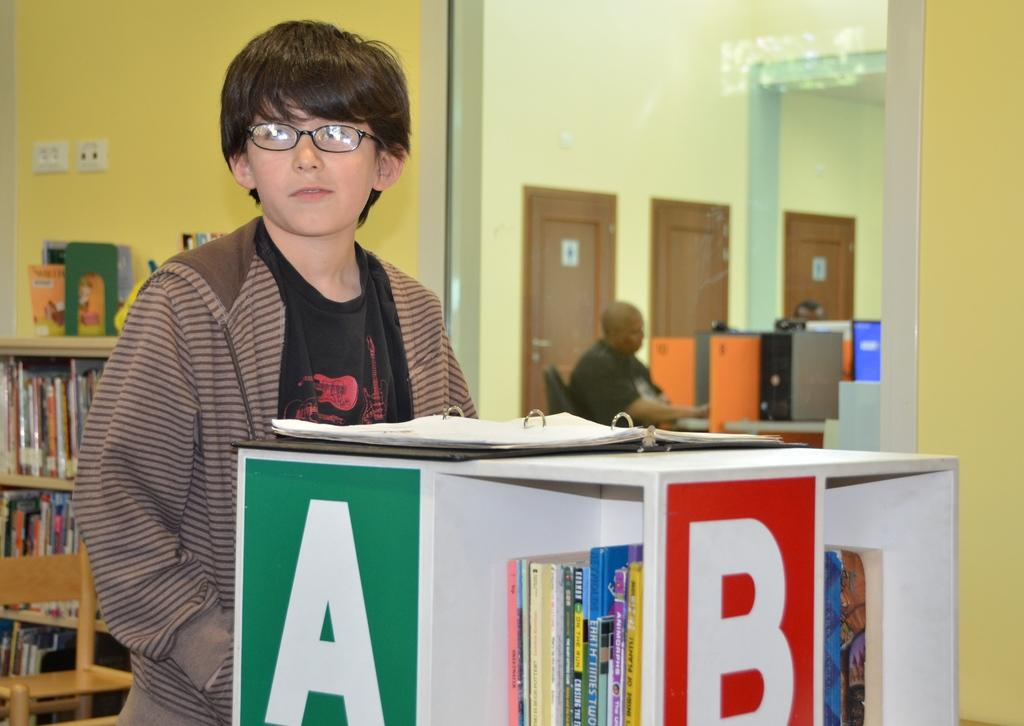<image>
Offer a succinct explanation of the picture presented. A young person standing behind a bookcase marked with a large A and B 